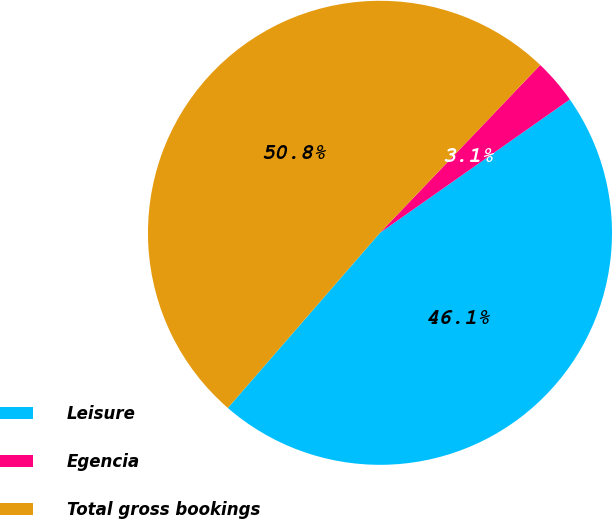Convert chart to OTSL. <chart><loc_0><loc_0><loc_500><loc_500><pie_chart><fcel>Leisure<fcel>Egencia<fcel>Total gross bookings<nl><fcel>46.13%<fcel>3.12%<fcel>50.75%<nl></chart> 